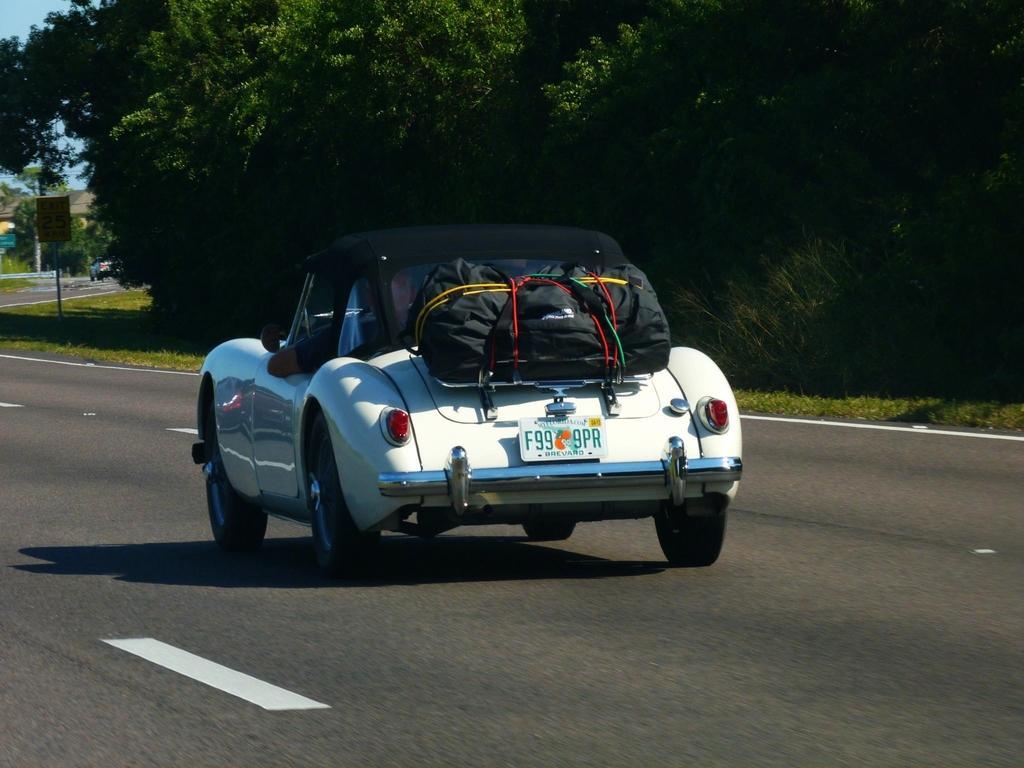Could you give a brief overview of what you see in this image? In this image I can see a vehicle which is in white color. We can see few bags on the vehicle and person is sitting inside. Back I can see trees and signboards. The sky is in blue color. 